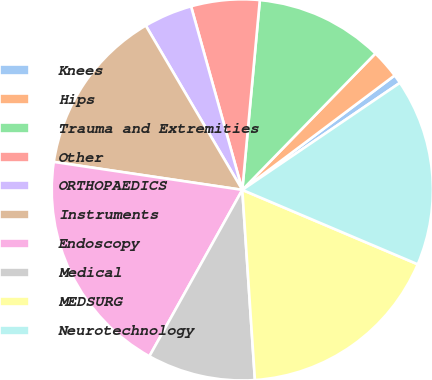Convert chart to OTSL. <chart><loc_0><loc_0><loc_500><loc_500><pie_chart><fcel>Knees<fcel>Hips<fcel>Trauma and Extremities<fcel>Other<fcel>ORTHOPAEDICS<fcel>Instruments<fcel>Endoscopy<fcel>Medical<fcel>MEDSURG<fcel>Neurotechnology<nl><fcel>0.76%<fcel>2.44%<fcel>10.84%<fcel>5.8%<fcel>4.12%<fcel>14.2%<fcel>19.24%<fcel>9.16%<fcel>17.56%<fcel>15.88%<nl></chart> 